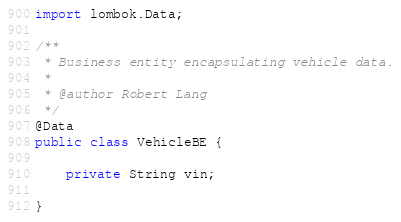<code> <loc_0><loc_0><loc_500><loc_500><_Java_>
import lombok.Data;

/**
 * Business entity encapsulating vehicle data.
 *
 * @author Robert Lang
 */
@Data
public class VehicleBE {

    private String vin;

}
</code> 